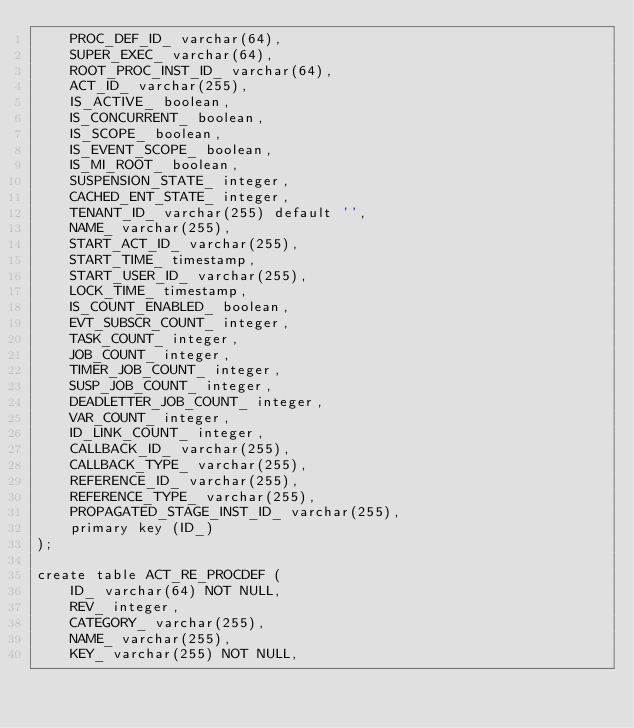<code> <loc_0><loc_0><loc_500><loc_500><_SQL_>    PROC_DEF_ID_ varchar(64),
    SUPER_EXEC_ varchar(64),
    ROOT_PROC_INST_ID_ varchar(64),
    ACT_ID_ varchar(255),
    IS_ACTIVE_ boolean,
    IS_CONCURRENT_ boolean,
    IS_SCOPE_ boolean,
    IS_EVENT_SCOPE_ boolean,
    IS_MI_ROOT_ boolean,
    SUSPENSION_STATE_ integer,
    CACHED_ENT_STATE_ integer,
    TENANT_ID_ varchar(255) default '',
    NAME_ varchar(255),
    START_ACT_ID_ varchar(255),
    START_TIME_ timestamp,
    START_USER_ID_ varchar(255),
    LOCK_TIME_ timestamp,
    IS_COUNT_ENABLED_ boolean,
    EVT_SUBSCR_COUNT_ integer, 
    TASK_COUNT_ integer, 
    JOB_COUNT_ integer, 
    TIMER_JOB_COUNT_ integer,
    SUSP_JOB_COUNT_ integer,
    DEADLETTER_JOB_COUNT_ integer,
    VAR_COUNT_ integer, 
    ID_LINK_COUNT_ integer,
    CALLBACK_ID_ varchar(255),
    CALLBACK_TYPE_ varchar(255),
    REFERENCE_ID_ varchar(255),
    REFERENCE_TYPE_ varchar(255),
    PROPAGATED_STAGE_INST_ID_ varchar(255),
    primary key (ID_)
);

create table ACT_RE_PROCDEF (
    ID_ varchar(64) NOT NULL,
    REV_ integer,
    CATEGORY_ varchar(255),
    NAME_ varchar(255),
    KEY_ varchar(255) NOT NULL,</code> 